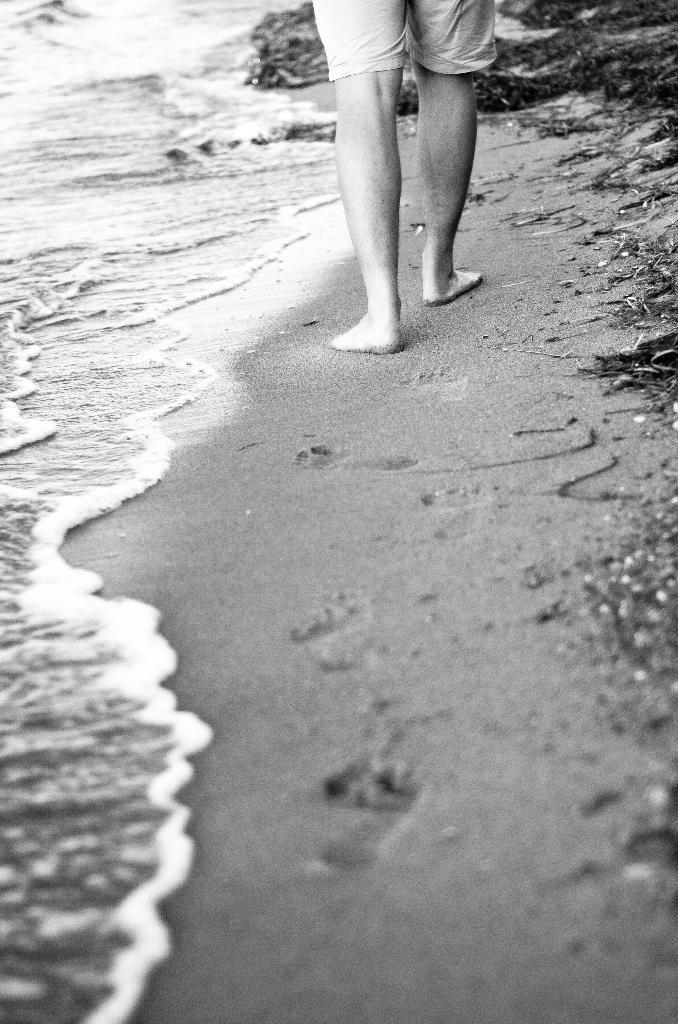What type of picture is in the image? The image contains a black and white picture. What is happening in the picture? The picture depicts a person standing on the ground. What can be seen on the left side of the image? There is water visible on the left side of the image. How many children are playing in the water on the left side of the image? There are no children present in the image, and the water is not depicted as a play area. 